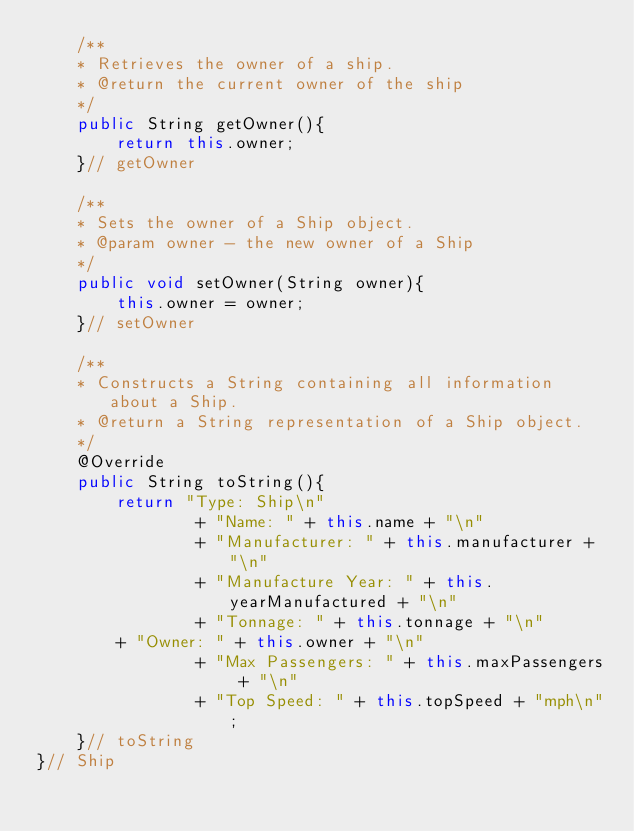Convert code to text. <code><loc_0><loc_0><loc_500><loc_500><_Java_>	/**
 	* Retrieves the owner of a ship.
 	* @return the current owner of the ship
 	*/ 
	public String getOwner(){
		return this.owner;
	}// getOwner

	/**
 	* Sets the owner of a Ship object.
 	* @param owner - the new owner of a Ship
 	*/
	public void setOwner(String owner){
		this.owner = owner;
	}// setOwner
	
	/**
 	* Constructs a String containing all information about a Ship.
 	* @return a String representation of a Ship object.
 	*/ 
	@Override
	public String toString(){
		return "Type: Ship\n" 
                + "Name: " + this.name + "\n"
                + "Manufacturer: " + this.manufacturer + "\n"
                + "Manufacture Year: " + this.yearManufactured + "\n"
                + "Tonnage: " + this.tonnage + "\n"
		+ "Owner: " + this.owner + "\n"
                + "Max Passengers: " + this.maxPassengers + "\n"
                + "Top Speed: " + this.topSpeed + "mph\n";
	}// toString
}// Ship
</code> 